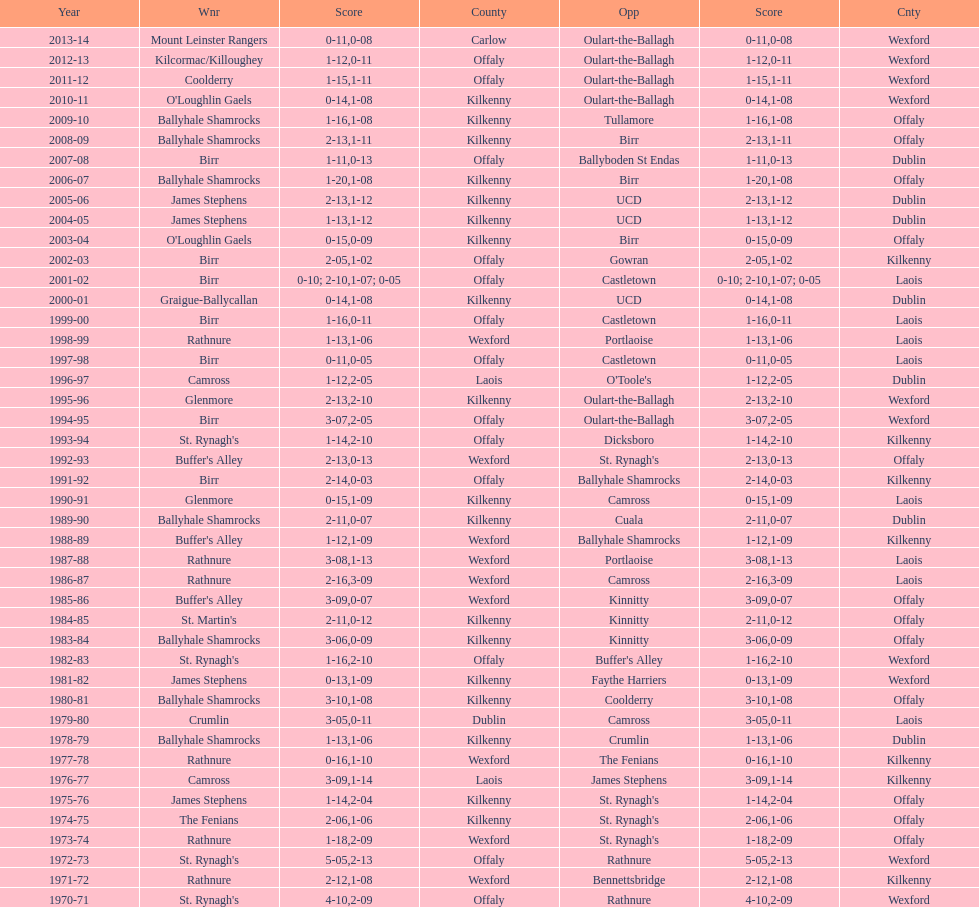Which team won the leinster senior club hurling championships previous to the last time birr won? Ballyhale Shamrocks. 